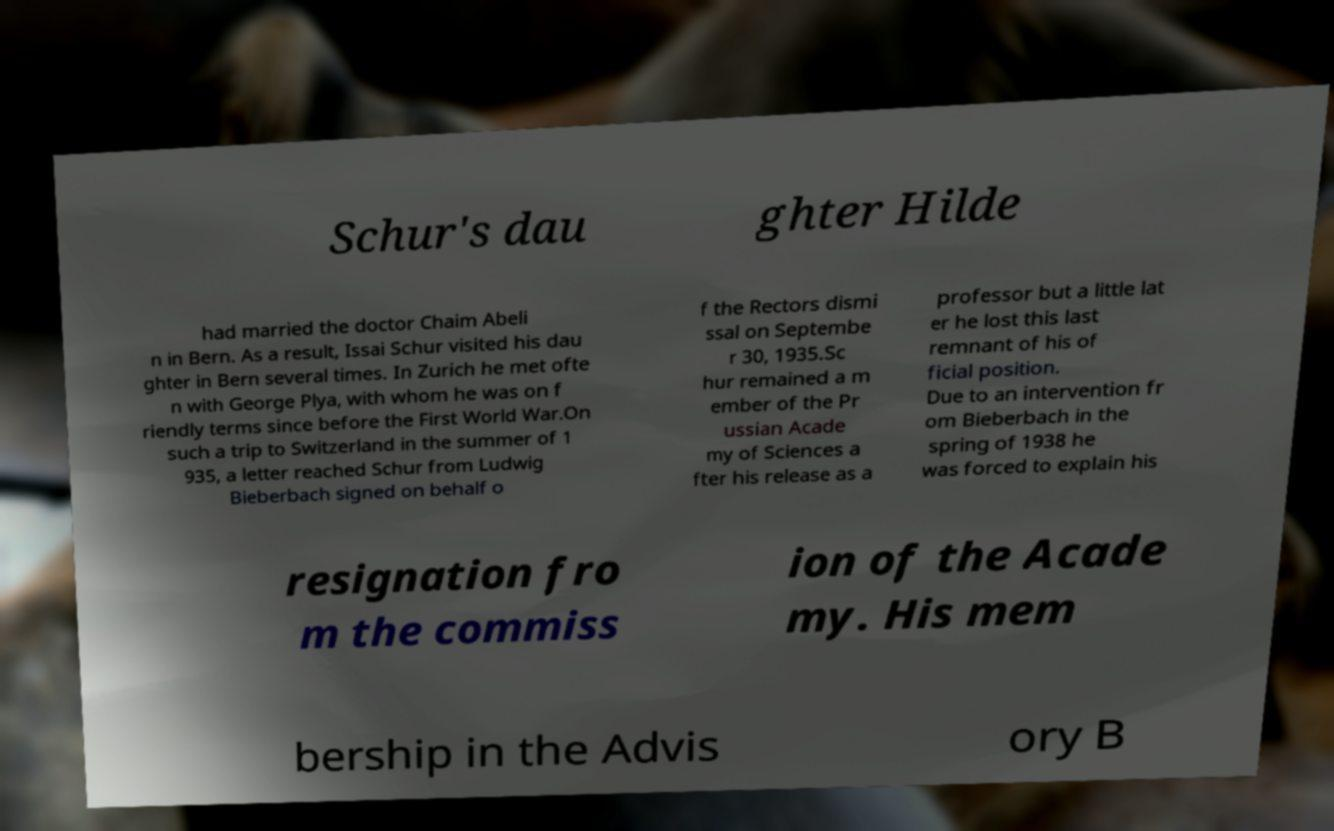I need the written content from this picture converted into text. Can you do that? Schur's dau ghter Hilde had married the doctor Chaim Abeli n in Bern. As a result, Issai Schur visited his dau ghter in Bern several times. In Zurich he met ofte n with George Plya, with whom he was on f riendly terms since before the First World War.On such a trip to Switzerland in the summer of 1 935, a letter reached Schur from Ludwig Bieberbach signed on behalf o f the Rectors dismi ssal on Septembe r 30, 1935.Sc hur remained a m ember of the Pr ussian Acade my of Sciences a fter his release as a professor but a little lat er he lost this last remnant of his of ficial position. Due to an intervention fr om Bieberbach in the spring of 1938 he was forced to explain his resignation fro m the commiss ion of the Acade my. His mem bership in the Advis ory B 